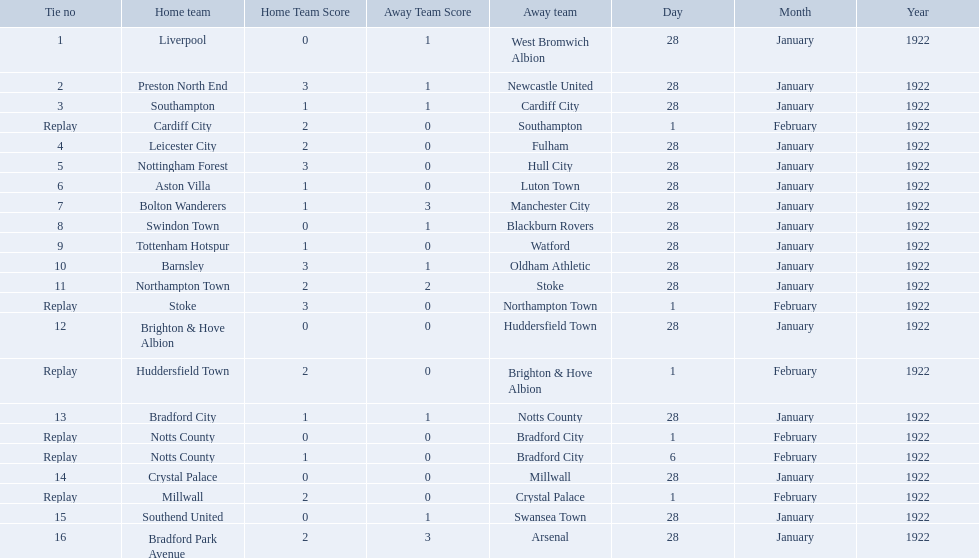What are all of the home teams? Liverpool, Preston North End, Southampton, Cardiff City, Leicester City, Nottingham Forest, Aston Villa, Bolton Wanderers, Swindon Town, Tottenham Hotspur, Barnsley, Northampton Town, Stoke, Brighton & Hove Albion, Huddersfield Town, Bradford City, Notts County, Notts County, Crystal Palace, Millwall, Southend United, Bradford Park Avenue. What were the scores? 0–1, 3–1, 1–1, 2–0, 2–0, 3–0, 1–0, 1–3, 0–1, 1–0, 3–1, 2–2, 3–0, 0–0, 2–0, 1–1, 0–0, 1–0, 0–0, 2–0, 0–1, 2–3. On which dates did they play? 28 January 1922, 28 January 1922, 28 January 1922, 1 February 1922, 28 January 1922, 28 January 1922, 28 January 1922, 28 January 1922, 28 January 1922, 28 January 1922, 28 January 1922, 28 January 1922, 1 February 1922, 28 January 1922, 1 February 1922, 28 January 1922, 1 February 1922, 6 February 1922, 28 January 1922, 1 February 1922, 28 January 1922, 28 January 1922. Which teams played on 28 january 1922? Liverpool, Preston North End, Southampton, Leicester City, Nottingham Forest, Aston Villa, Bolton Wanderers, Swindon Town, Tottenham Hotspur, Barnsley, Northampton Town, Brighton & Hove Albion, Bradford City, Crystal Palace, Southend United, Bradford Park Avenue. Of those, which scored the same as aston villa? Tottenham Hotspur. 